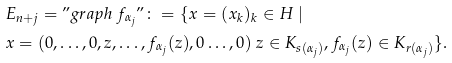Convert formula to latex. <formula><loc_0><loc_0><loc_500><loc_500>& E _ { n + j } = " g r a p h \ f _ { \alpha _ { j } } " \colon = \{ x = ( x _ { k } ) _ { k } \in H \ | \\ & x = ( 0 , \dots , 0 , z , \dots , f _ { \alpha _ { j } } ( z ) , 0 \dots , 0 ) \ z \in K _ { s ( \alpha _ { j } ) } , f _ { \alpha _ { j } } ( z ) \in K _ { r ( \alpha _ { j } ) } \} .</formula> 